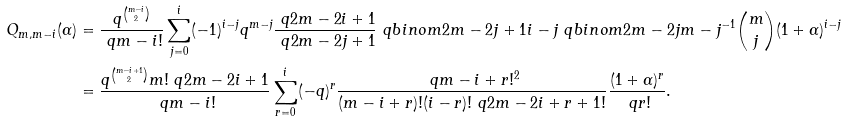Convert formula to latex. <formula><loc_0><loc_0><loc_500><loc_500>Q _ { m , m - i } ( \alpha ) & = \frac { q ^ { \binom { m - i } 2 } } { \ q { m - i } ! } \sum _ { j = 0 } ^ { i } ( - 1 ) ^ { i - j } q ^ { m - j } \frac { \ q { 2 m - 2 i + 1 } } { \ q { 2 m - 2 j + 1 } } \ q b i n o m { 2 m - 2 j + 1 } { i - j } \ q b i n o m { 2 m - 2 j } { m - j } ^ { - 1 } \binom { m } { j } ( 1 + \alpha ) ^ { i - j } \\ & = \frac { q ^ { \binom { m - i + 1 } 2 } m ! \ q { 2 m - 2 i + 1 } } { \ q { m - i } ! } \sum _ { r = 0 } ^ { i } ( - q ) ^ { r } \frac { \ q { m - i + r } ! ^ { 2 } } { ( m - i + r ) ! ( i - r ) ! \ q { 2 m - 2 i + r + 1 } ! } \frac { ( 1 + \alpha ) ^ { r } } { \ q { r } ! } .</formula> 